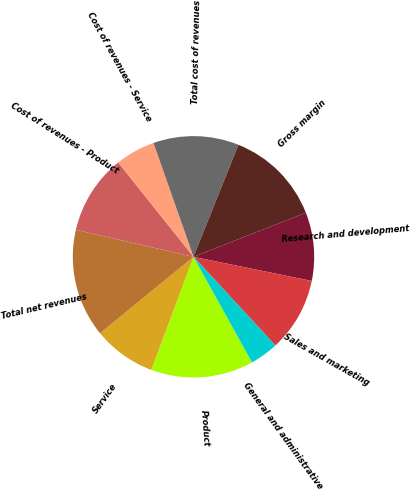<chart> <loc_0><loc_0><loc_500><loc_500><pie_chart><fcel>Product<fcel>Service<fcel>Total net revenues<fcel>Cost of revenues - Product<fcel>Cost of revenues - Service<fcel>Total cost of revenues<fcel>Gross margin<fcel>Research and development<fcel>Sales and marketing<fcel>General and administrative<nl><fcel>13.74%<fcel>8.4%<fcel>14.5%<fcel>10.69%<fcel>5.34%<fcel>11.45%<fcel>12.98%<fcel>9.16%<fcel>9.92%<fcel>3.82%<nl></chart> 